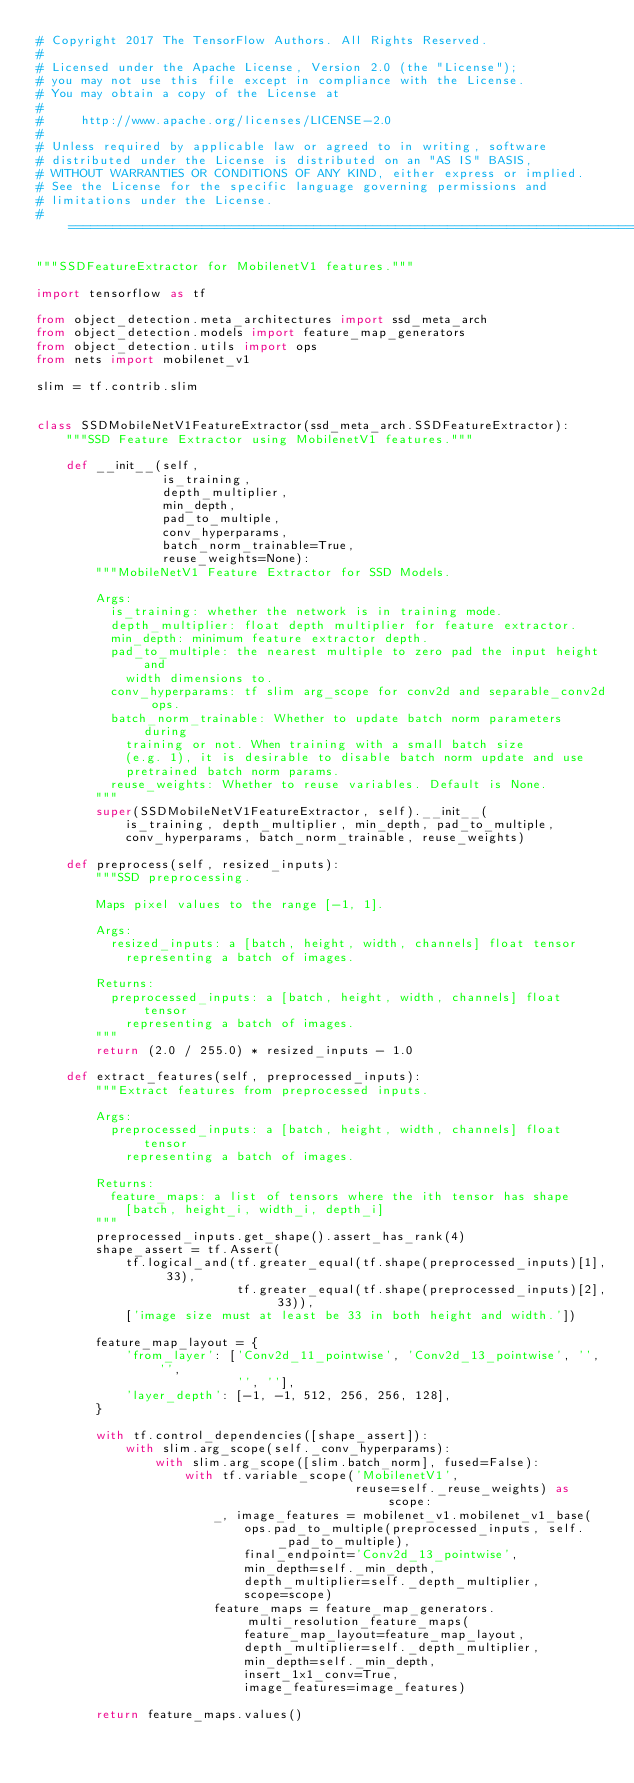<code> <loc_0><loc_0><loc_500><loc_500><_Python_># Copyright 2017 The TensorFlow Authors. All Rights Reserved.
#
# Licensed under the Apache License, Version 2.0 (the "License");
# you may not use this file except in compliance with the License.
# You may obtain a copy of the License at
#
#     http://www.apache.org/licenses/LICENSE-2.0
#
# Unless required by applicable law or agreed to in writing, software
# distributed under the License is distributed on an "AS IS" BASIS,
# WITHOUT WARRANTIES OR CONDITIONS OF ANY KIND, either express or implied.
# See the License for the specific language governing permissions and
# limitations under the License.
# ==============================================================================

"""SSDFeatureExtractor for MobilenetV1 features."""

import tensorflow as tf

from object_detection.meta_architectures import ssd_meta_arch
from object_detection.models import feature_map_generators
from object_detection.utils import ops
from nets import mobilenet_v1

slim = tf.contrib.slim


class SSDMobileNetV1FeatureExtractor(ssd_meta_arch.SSDFeatureExtractor):
    """SSD Feature Extractor using MobilenetV1 features."""

    def __init__(self,
                 is_training,
                 depth_multiplier,
                 min_depth,
                 pad_to_multiple,
                 conv_hyperparams,
                 batch_norm_trainable=True,
                 reuse_weights=None):
        """MobileNetV1 Feature Extractor for SSD Models.

        Args:
          is_training: whether the network is in training mode.
          depth_multiplier: float depth multiplier for feature extractor.
          min_depth: minimum feature extractor depth.
          pad_to_multiple: the nearest multiple to zero pad the input height and
            width dimensions to.
          conv_hyperparams: tf slim arg_scope for conv2d and separable_conv2d ops.
          batch_norm_trainable: Whether to update batch norm parameters during
            training or not. When training with a small batch size
            (e.g. 1), it is desirable to disable batch norm update and use
            pretrained batch norm params.
          reuse_weights: Whether to reuse variables. Default is None.
        """
        super(SSDMobileNetV1FeatureExtractor, self).__init__(
            is_training, depth_multiplier, min_depth, pad_to_multiple,
            conv_hyperparams, batch_norm_trainable, reuse_weights)

    def preprocess(self, resized_inputs):
        """SSD preprocessing.

        Maps pixel values to the range [-1, 1].

        Args:
          resized_inputs: a [batch, height, width, channels] float tensor
            representing a batch of images.

        Returns:
          preprocessed_inputs: a [batch, height, width, channels] float tensor
            representing a batch of images.
        """
        return (2.0 / 255.0) * resized_inputs - 1.0

    def extract_features(self, preprocessed_inputs):
        """Extract features from preprocessed inputs.

        Args:
          preprocessed_inputs: a [batch, height, width, channels] float tensor
            representing a batch of images.

        Returns:
          feature_maps: a list of tensors where the ith tensor has shape
            [batch, height_i, width_i, depth_i]
        """
        preprocessed_inputs.get_shape().assert_has_rank(4)
        shape_assert = tf.Assert(
            tf.logical_and(tf.greater_equal(tf.shape(preprocessed_inputs)[1], 33),
                           tf.greater_equal(tf.shape(preprocessed_inputs)[2], 33)),
            ['image size must at least be 33 in both height and width.'])

        feature_map_layout = {
            'from_layer': ['Conv2d_11_pointwise', 'Conv2d_13_pointwise', '', '',
                           '', ''],
            'layer_depth': [-1, -1, 512, 256, 256, 128],
        }

        with tf.control_dependencies([shape_assert]):
            with slim.arg_scope(self._conv_hyperparams):
                with slim.arg_scope([slim.batch_norm], fused=False):
                    with tf.variable_scope('MobilenetV1',
                                           reuse=self._reuse_weights) as scope:
                        _, image_features = mobilenet_v1.mobilenet_v1_base(
                            ops.pad_to_multiple(preprocessed_inputs, self._pad_to_multiple),
                            final_endpoint='Conv2d_13_pointwise',
                            min_depth=self._min_depth,
                            depth_multiplier=self._depth_multiplier,
                            scope=scope)
                        feature_maps = feature_map_generators.multi_resolution_feature_maps(
                            feature_map_layout=feature_map_layout,
                            depth_multiplier=self._depth_multiplier,
                            min_depth=self._min_depth,
                            insert_1x1_conv=True,
                            image_features=image_features)

        return feature_maps.values()
</code> 